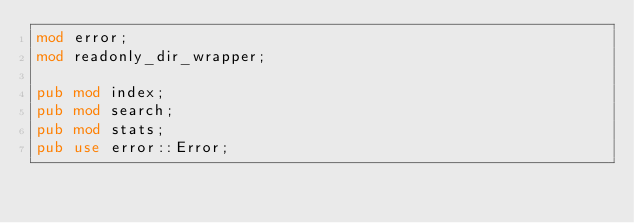<code> <loc_0><loc_0><loc_500><loc_500><_Rust_>mod error;
mod readonly_dir_wrapper;

pub mod index;
pub mod search;
pub mod stats;
pub use error::Error;
</code> 